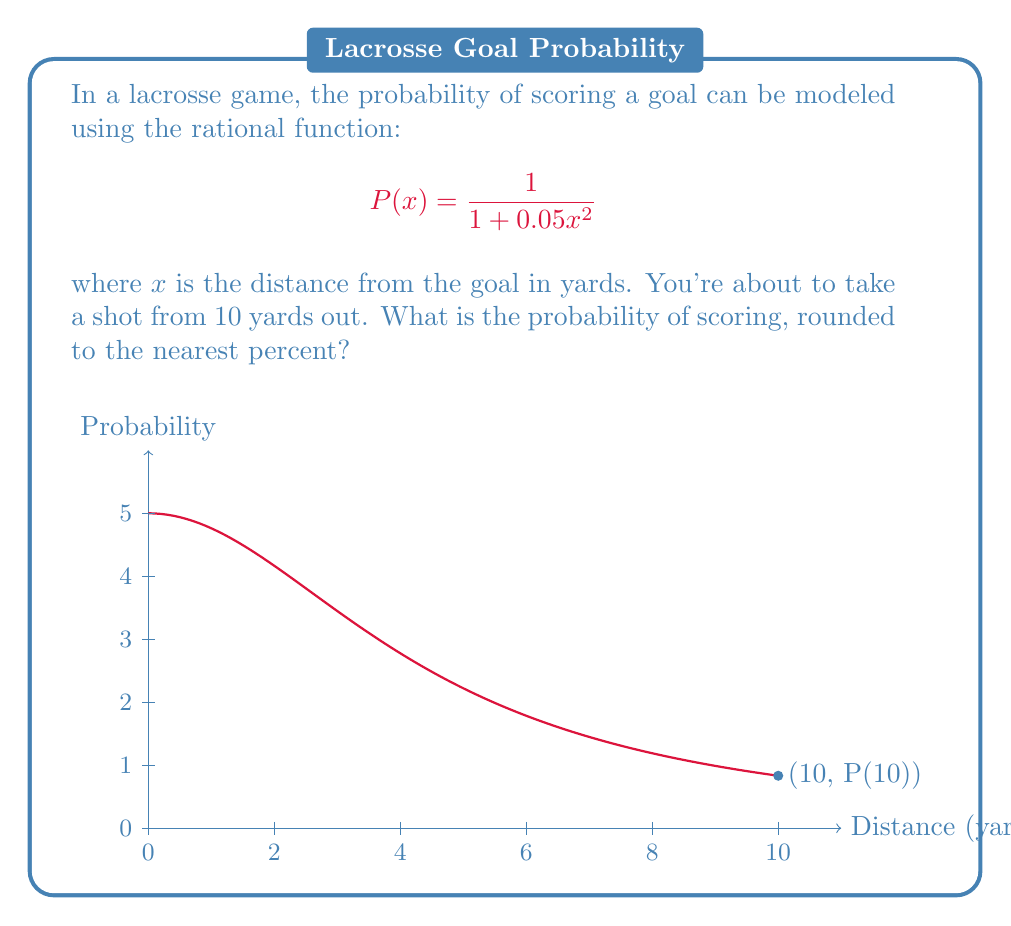Teach me how to tackle this problem. Let's approach this step-by-step:

1) We're given the probability function:
   $$P(x) = \frac{1}{1 + 0.05x^2}$$

2) We need to find P(10), as we're shooting from 10 yards out:
   $$P(10) = \frac{1}{1 + 0.05(10)^2}$$

3) Let's simplify the denominator:
   $$P(10) = \frac{1}{1 + 0.05(100)}$$
   $$P(10) = \frac{1}{1 + 5}$$
   $$P(10) = \frac{1}{6}$$

4) To convert this to a percentage:
   $$\frac{1}{6} \approx 0.1667$$

5) Multiplying by 100 and rounding to the nearest percent:
   $$0.1667 * 100 \approx 16.67\%$$
   Rounded to the nearest percent: 17%

Therefore, the probability of scoring from 10 yards out is approximately 17%.
Answer: 17% 